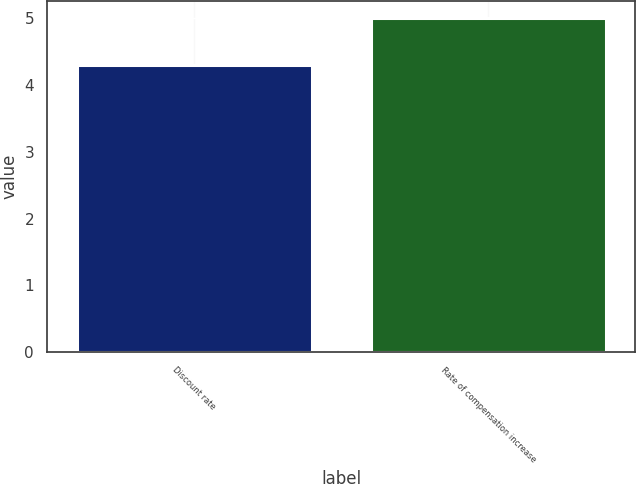Convert chart to OTSL. <chart><loc_0><loc_0><loc_500><loc_500><bar_chart><fcel>Discount rate<fcel>Rate of compensation increase<nl><fcel>4.3<fcel>5<nl></chart> 